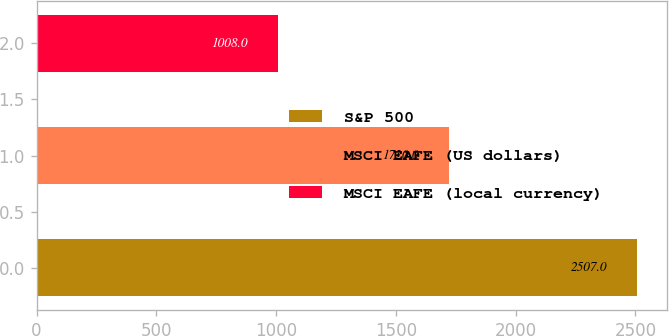Convert chart to OTSL. <chart><loc_0><loc_0><loc_500><loc_500><bar_chart><fcel>S&P 500<fcel>MSCI EAFE (US dollars)<fcel>MSCI EAFE (local currency)<nl><fcel>2507<fcel>1720<fcel>1008<nl></chart> 